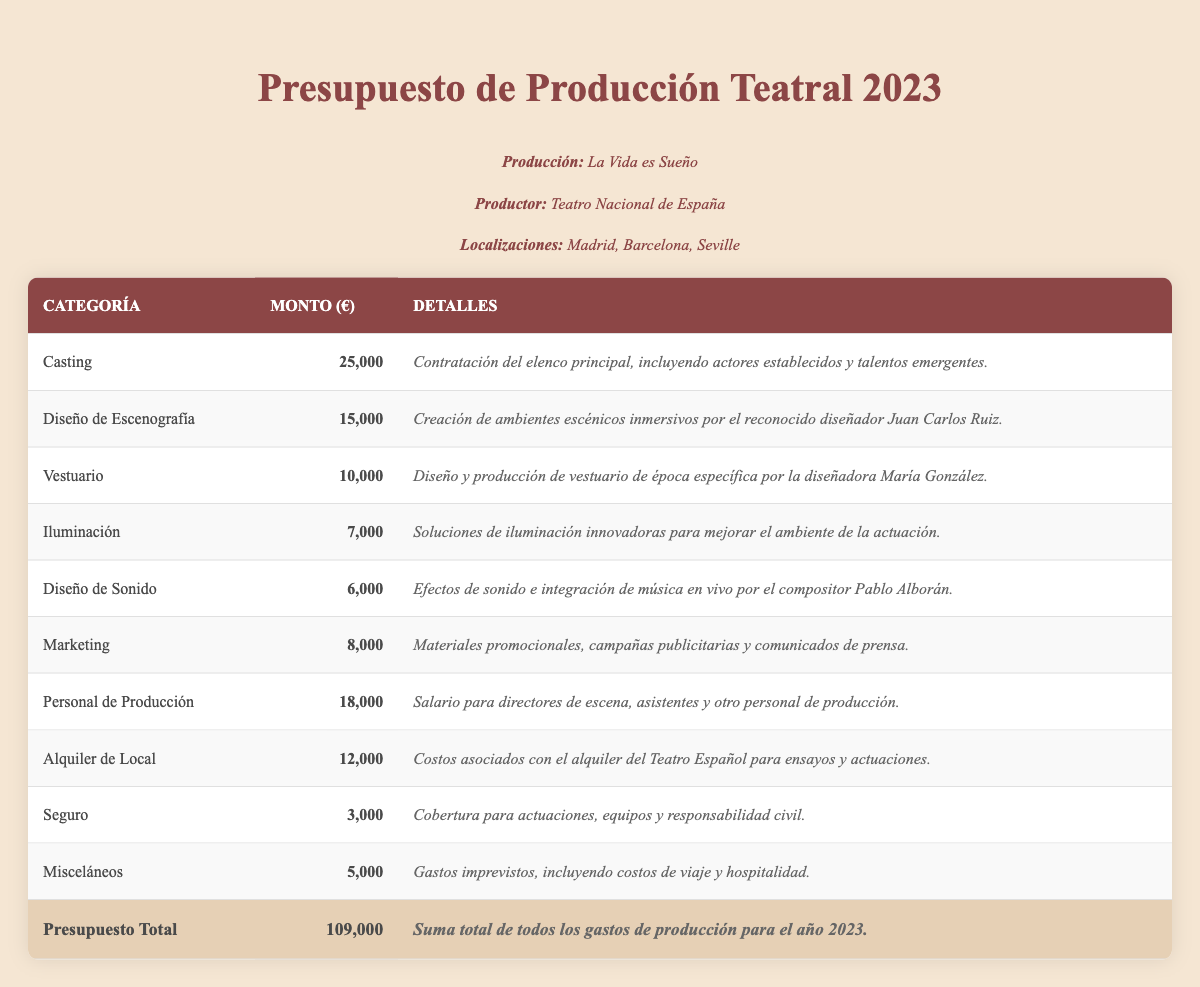¿Cuál es el monto destinado a la categoría de Casting? En la tabla, el monto destinado a la categoría de Casting se encuentra en la columna correspondiente y es de 25,000 euros.
Answer: 25,000 ¿Cuánto total se ha asignado a Marketing? El monto específico para la categoría de Marketing se puede leer en la tabla y es de 8,000 euros.
Answer: 8,000 ¿Es cierto que el costo de Seguro es menor que el de Iluminación? Al comparar los montos en la tabla, se observa que el costo de Seguro es 3,000 euros y el de Iluminación es 7,000 euros, por lo que la afirmación es verdadera.
Answer: Sí ¿Qué es más: el costo del Diseño de Escenografía o el de Vestuario? El costo del Diseño de Escenografía es de 15,000 euros y el del Vestuario es de 10,000 euros. Comparando ambos, el Diseño de Escenografía tiene un mayor costo.
Answer: Diseño de Escenografía ¿Cuál es el total de los gastos de Producción Staff y Alquiler de Local? Para calcular el total, sumamos el monto de Producción Staff que es 18,000 euros y el Alquiler de Local que es 12,000 euros: 18,000 + 12,000 = 30,000 euros.
Answer: 30,000 ¿Cuál es la categoría con el menor gasto entre las listadas? Al revisar los montos en la tabla, el gasto más bajo es el de Seguro con 3,000 euros.
Answer: Seguro Si sumamos el presupuesto total del Teatro Español (12,000 euros) y el de Marketing (8,000 euros), ¿cuánto es en total? La suma de 12,000 euros por Alquiler de Local y 8,000 euros por Marketing es 20,000 euros.
Answer: 20,000 ¿Cuál es la diferencia entre el monto de Casting y el monto de Costumes? El monto destinado a Casting es 25,000 euros y el de Costumes es 10,000 euros. La diferencia se calcula restando: 25,000 - 10,000 = 15,000 euros.
Answer: 15,000 Cuánto representa el costo de Iluminación respecto al total del presupuesto? Para encontrar el porcentaje del costo de Iluminación, que es 7,000 euros, comparado con el total de 100,000 euros, se calcula así: (7,000 / 100,000) * 100 = 7%.
Answer: 7% Si consideramos los costos de Diseño de Sonido y Marketing juntos, ¿cuál es el porcentaje que representan del total del presupuesto? El costo de Diseño de Sonido es 6,000 euros y Marketing es 8,000 euros. Su suma es 14,000 euros. Para encontrar el porcentaje, calculamos (14,000 / 100,000) * 100 = 14%.
Answer: 14% 